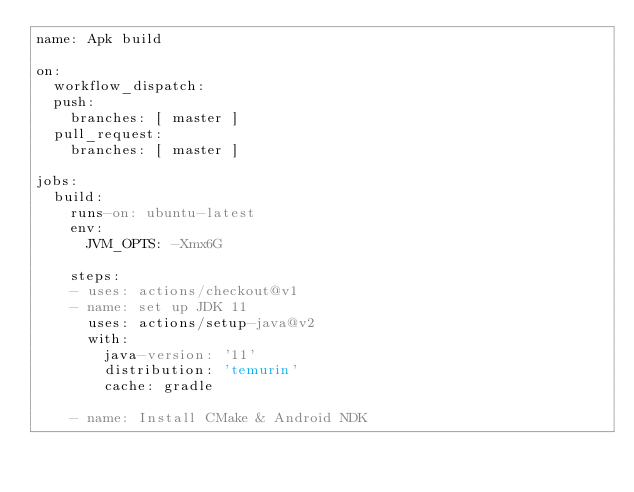<code> <loc_0><loc_0><loc_500><loc_500><_YAML_>name: Apk build

on:
  workflow_dispatch:
  push:
    branches: [ master ]
  pull_request:
    branches: [ master ]

jobs:
  build:
    runs-on: ubuntu-latest
    env:
      JVM_OPTS: -Xmx6G

    steps:
    - uses: actions/checkout@v1
    - name: set up JDK 11
      uses: actions/setup-java@v2
      with:
        java-version: '11'
        distribution: 'temurin'
        cache: gradle

    - name: Install CMake & Android NDK</code> 